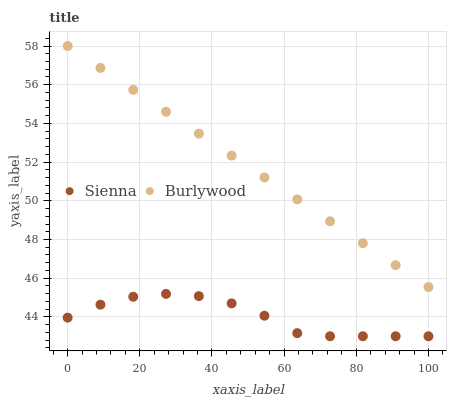Does Sienna have the minimum area under the curve?
Answer yes or no. Yes. Does Burlywood have the maximum area under the curve?
Answer yes or no. Yes. Does Burlywood have the minimum area under the curve?
Answer yes or no. No. Is Burlywood the smoothest?
Answer yes or no. Yes. Is Sienna the roughest?
Answer yes or no. Yes. Is Burlywood the roughest?
Answer yes or no. No. Does Sienna have the lowest value?
Answer yes or no. Yes. Does Burlywood have the lowest value?
Answer yes or no. No. Does Burlywood have the highest value?
Answer yes or no. Yes. Is Sienna less than Burlywood?
Answer yes or no. Yes. Is Burlywood greater than Sienna?
Answer yes or no. Yes. Does Sienna intersect Burlywood?
Answer yes or no. No. 